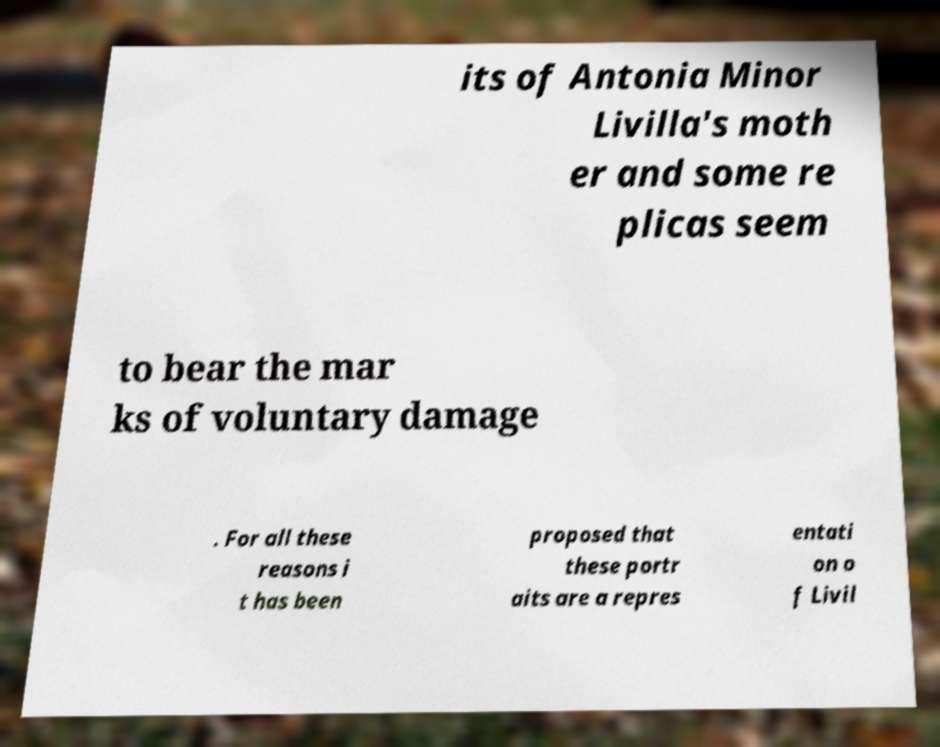Please identify and transcribe the text found in this image. its of Antonia Minor Livilla's moth er and some re plicas seem to bear the mar ks of voluntary damage . For all these reasons i t has been proposed that these portr aits are a repres entati on o f Livil 